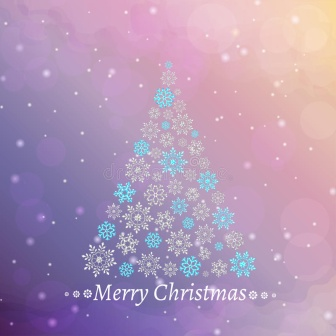Can you craft a short poem inspired by this image? Amidst the winter's gentle embrace,
A tree of snowflakes takes its place.
Against the sky in purple and pink hue,
A festive wish in cursive true.
'Merry Christmas' it softly sings,
Bringing joy on angel's wings.
In the silent night, the snow doth fall,
A serene holiday for one and all. 